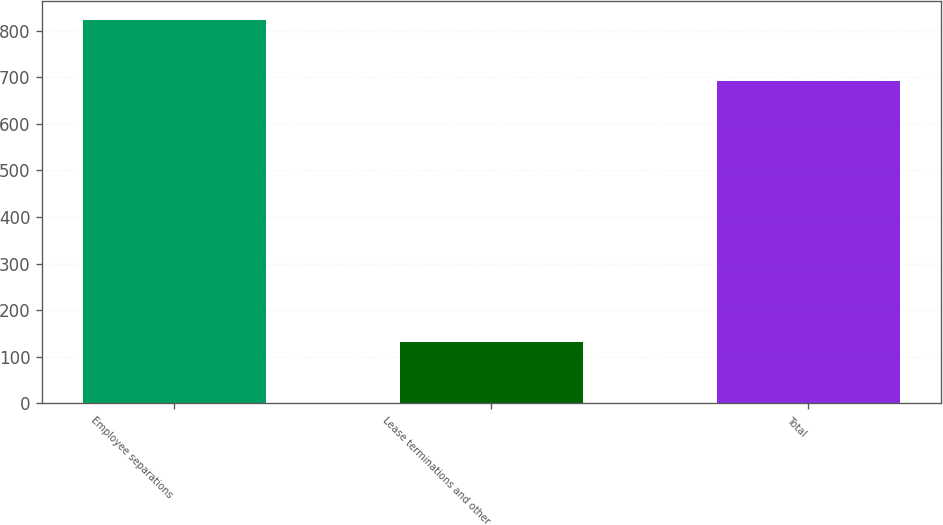<chart> <loc_0><loc_0><loc_500><loc_500><bar_chart><fcel>Employee separations<fcel>Lease terminations and other<fcel>Total<nl><fcel>823<fcel>131<fcel>692<nl></chart> 